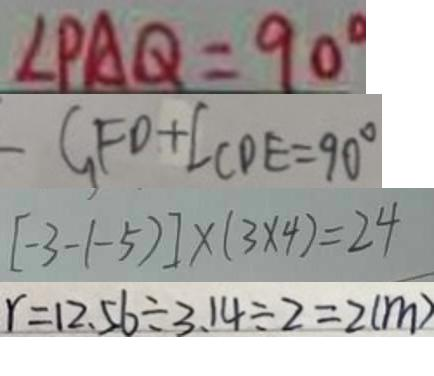<formula> <loc_0><loc_0><loc_500><loc_500>\angle P A Q = 9 0 ^ { \circ } 
 C F D + \angle C D E = 9 0 ^ { \circ } 
 [ - 3 - ( - 5 ) ] \times ( 3 \times 4 ) = 2 4 
 r = 1 2 . 5 6 \div 3 . 1 4 \div 2 = 2 ( m )</formula> 